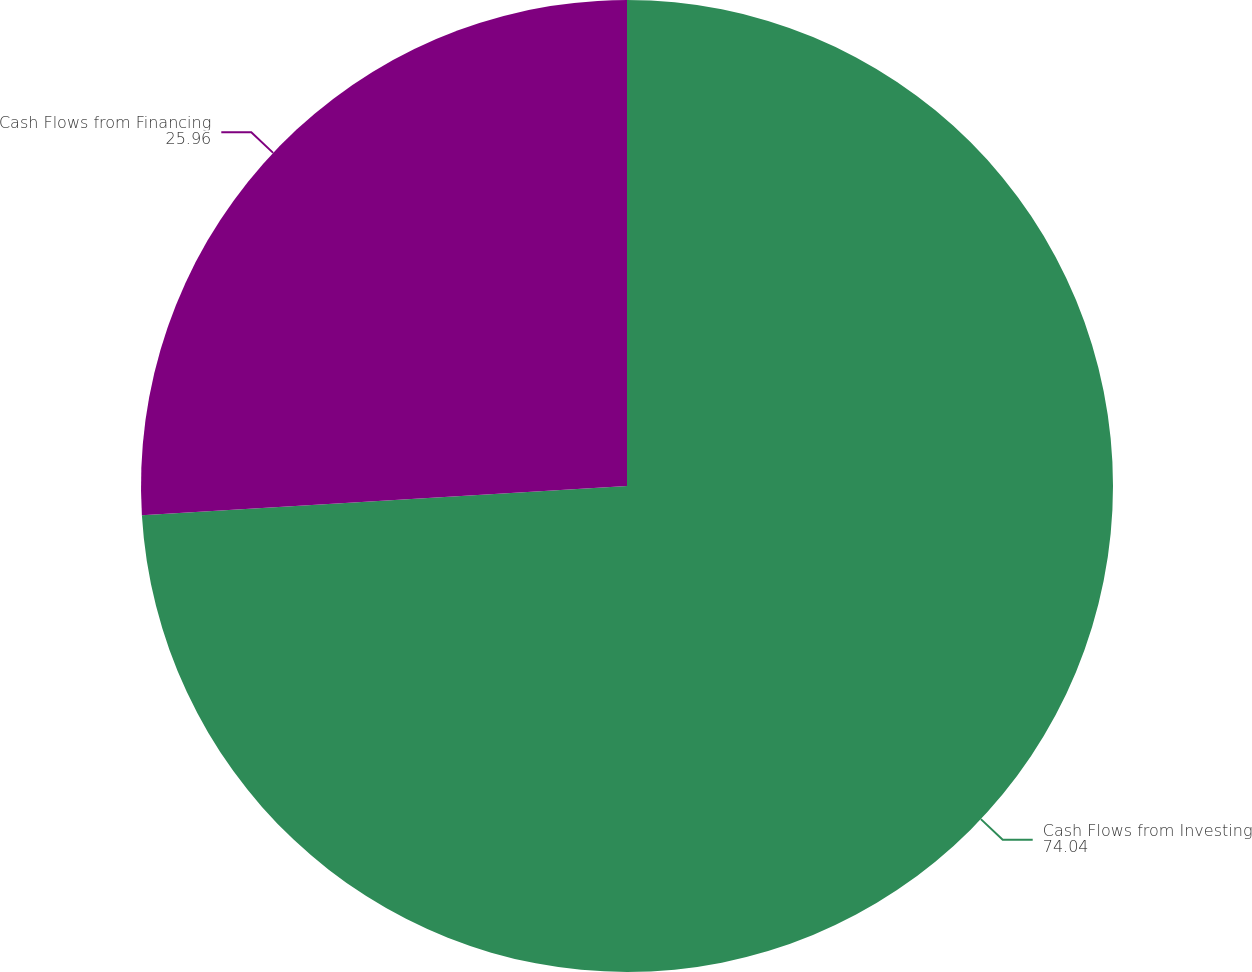Convert chart. <chart><loc_0><loc_0><loc_500><loc_500><pie_chart><fcel>Cash Flows from Investing<fcel>Cash Flows from Financing<nl><fcel>74.04%<fcel>25.96%<nl></chart> 